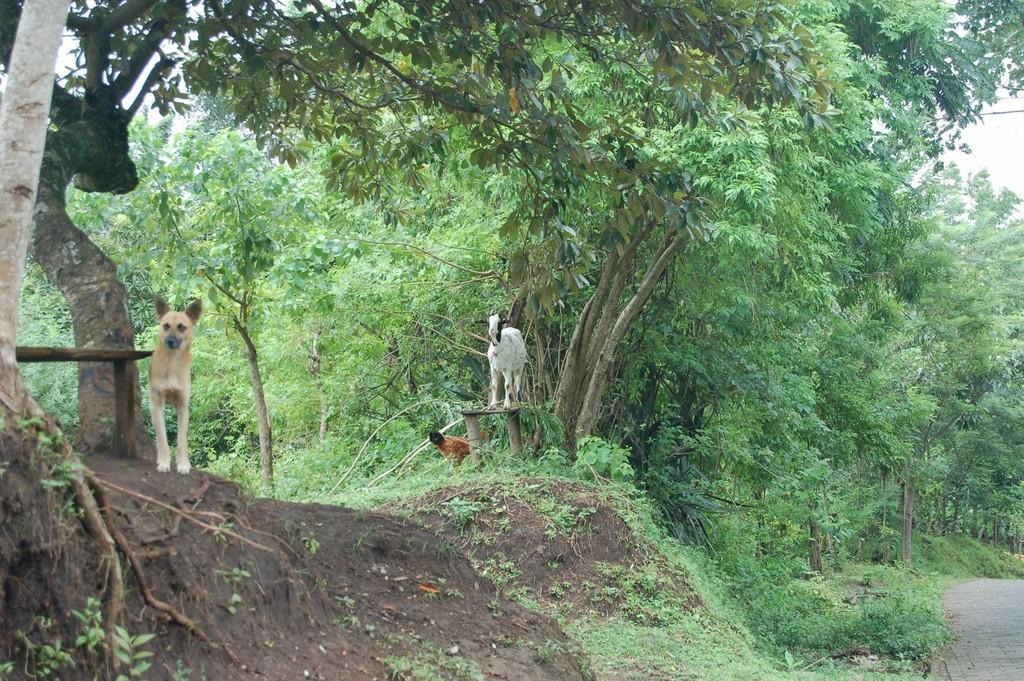Could you give a brief overview of what you see in this image? In this image I can see trees and I can see dogs visible in front of trees. 